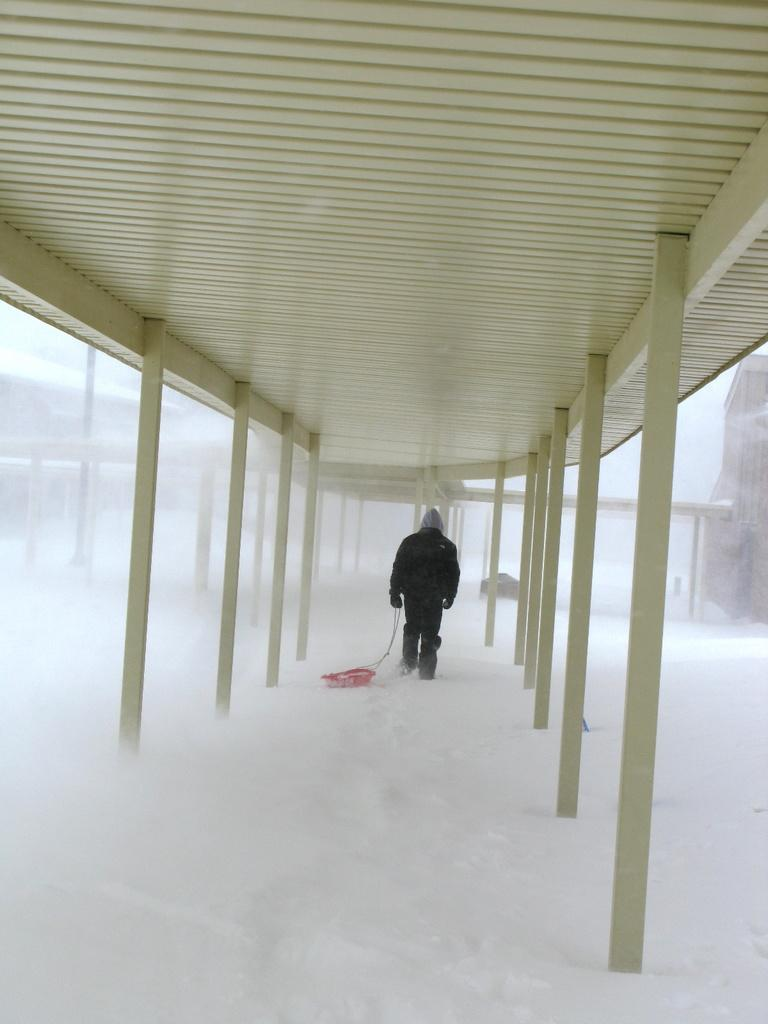What type of structure is visible in the image? There is a shed in the image. What is the person in the image doing? The person is walking on the snow. What is the person holding in the image? The person is holding an object. What other structure can be seen in the image? There is a house on the right side of the image. What type of mark can be seen on the person's face in the image? There is no mark visible on the person's face in the image. What message of peace is being conveyed by the person in the image? The image does not convey any message of peace, as it only shows a person walking on the snow while holding an object. 